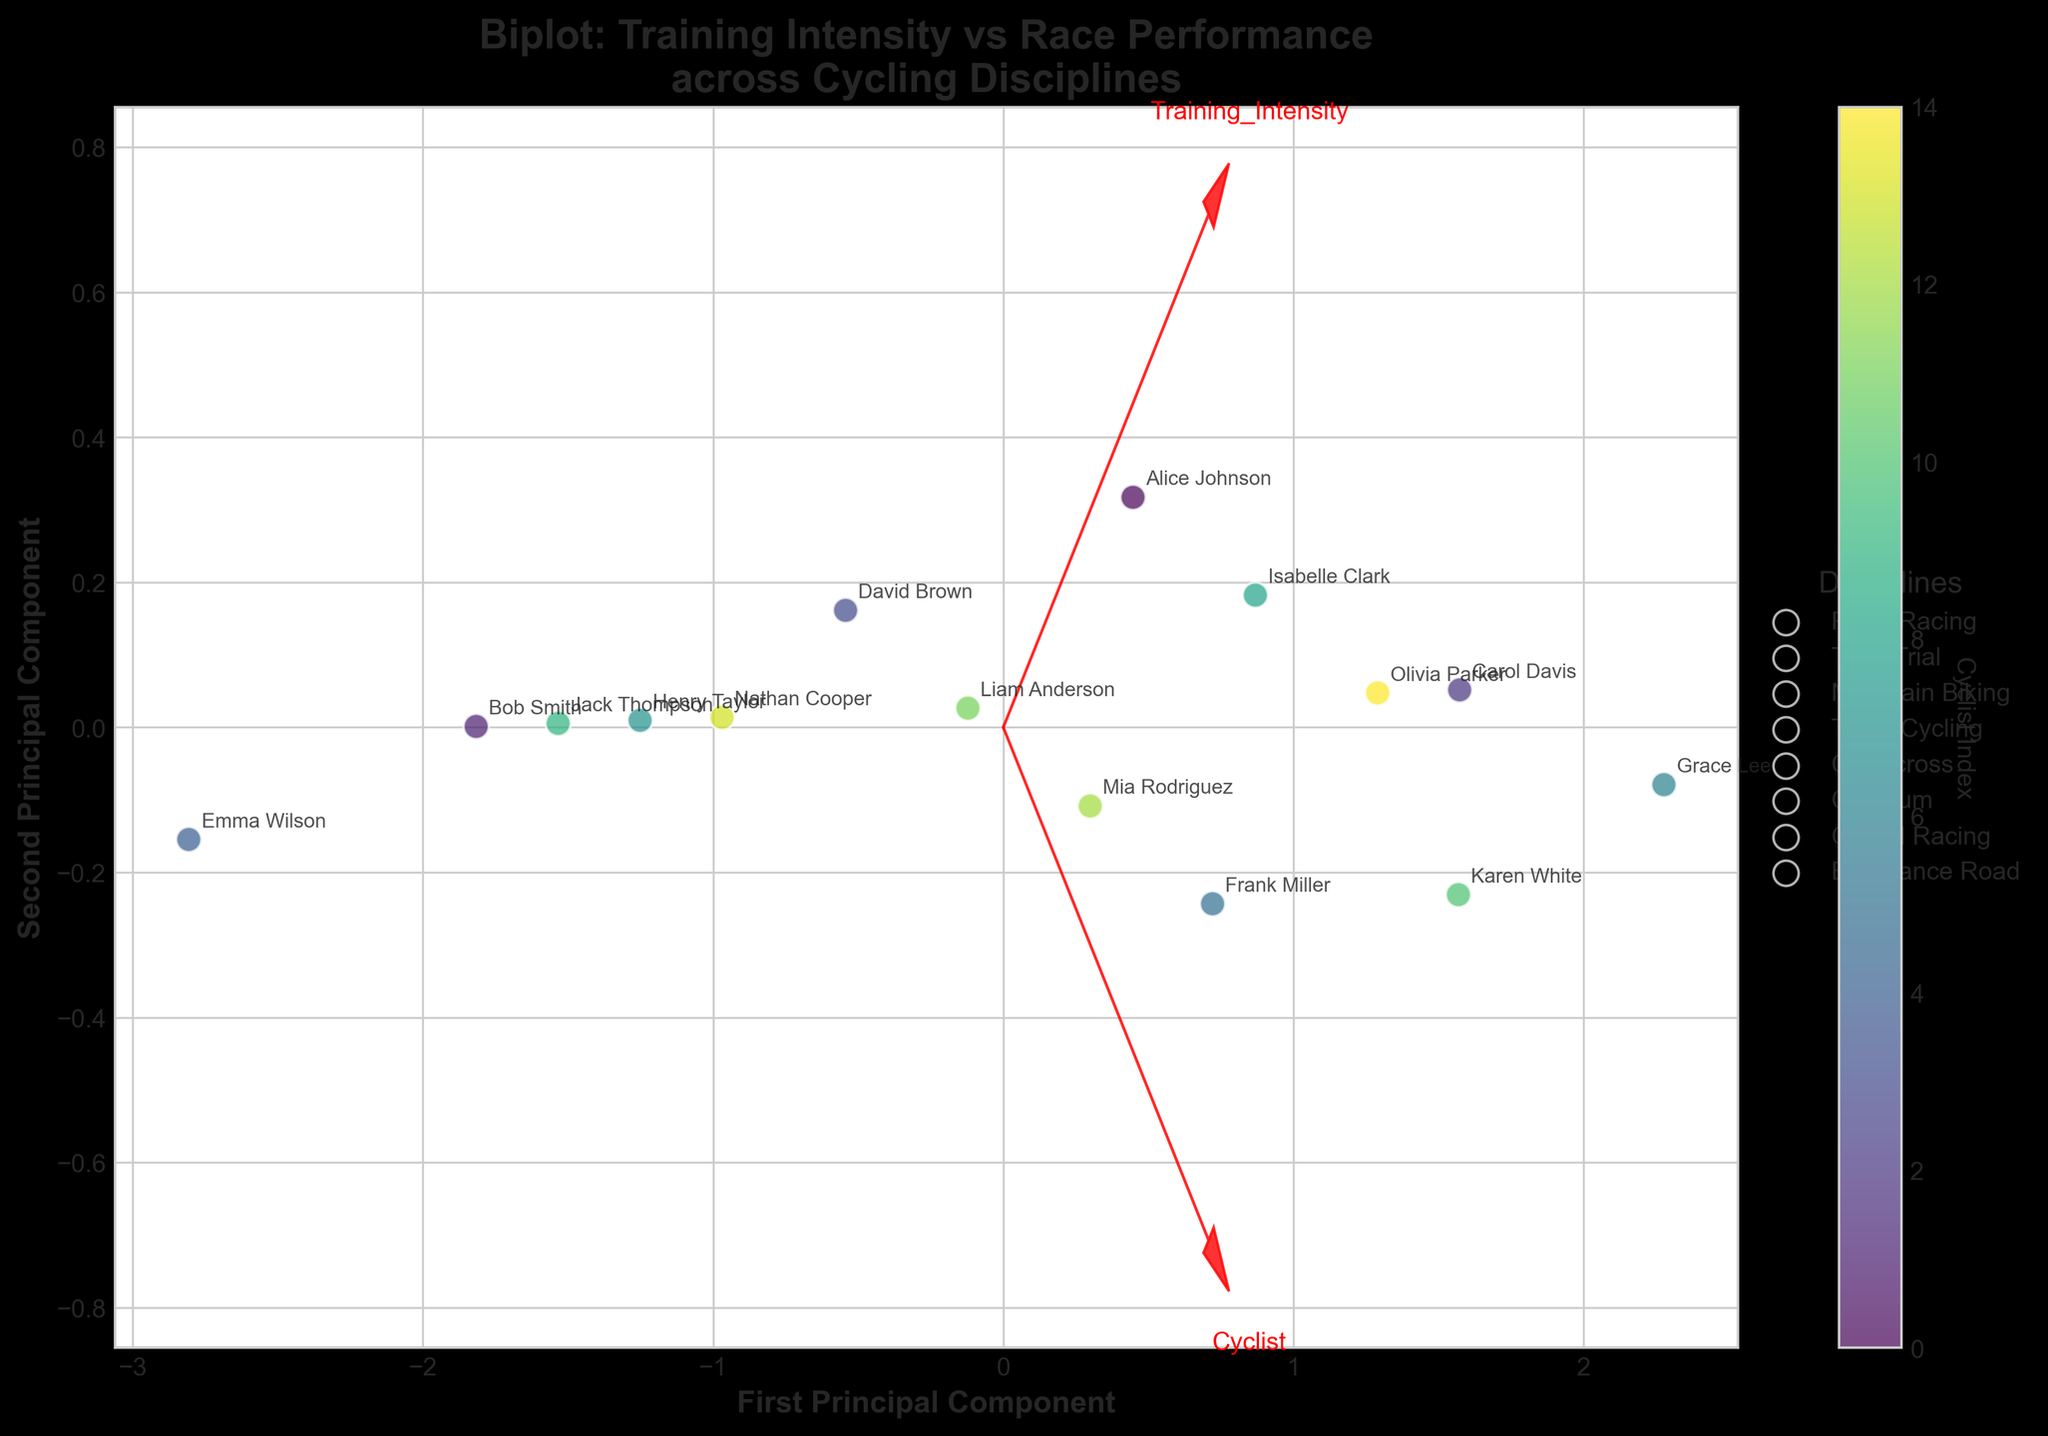what is the title of the figure? The title is often located at the top of the figure and it summarizes what the figure is about. For this figure, reading the text at the top reveals the title.
Answer: Biplot: Training Intensity vs Race Performance across Cycling Disciplines How many different cycling disciplines are represented in the plot? Each distinct cycling discipline is represented in the legend. Counting the number of items in the legend will give the total number of disciplines in the figure.
Answer: 7 Which cyclist corresponds to the highest value along the first principal component? To identify the cyclist, locate the data point that is furthest to the right along the x-axis (first principal component), and check the associated annotation.
Answer: Grace Lee Between Road Racing and Mountain Biking, which discipline shows a higher spread in Training Intensity and Race Performance? Examine the spread of data points for each discipline by observing the scatter plot locations. Road Racing data points should be compared with Mountain Biking data points to see which discipline has a wider spread on both axes.
Answer: Road Racing What do the red arrows in the biplot represent? The red arrows in a biplot usually represent the feature vectors in the PCA space. By looking at the figure, we can observe that the arrows are labeled which hints at the underlying features they represent.
Answer: Feature vectors for Training Intensity and Race Performance Is there any cyclist with nearly equal contribution to both principal components? Cycles with equal contributions to both principal components will be closer to the origin of the plot. Identifying the plotted point closest to zero on both axes will reveal this cyclist.
Answer: No, none are exactly equal but closest is Emma Wilson Which two disciplines appear to be the most similar in terms of PCA results? By observing the clusters of colors (representing disciplines) in the PCA plot, identify which two disciplines have data points that are most closely grouped together or overlap significantly.
Answer: Time Trial and Criterium Is there a positive correlation between Training Intensity and Race Performance implied by the plot? A positive correlation would be indicated by vectors pointing in similar directions. By examining the direction of the arrows for Training Intensity and Race Performance, we can determine the nature of their relationship.
Answer: Yes Which axis on the plot represents the first principal component? The axis labeled as 'First Principal Component' typically represents this. In the figure, the x-axis is labeled accordingly.
Answer: X-axis How does the position of Henry Taylor compare to the average position of Track Cycling cyclists on the plot? To answer this, identify Henry Taylor's data point and compare its position to the cluster of points representing Track Cycling cyclists.
Answer: Slightly below average on the y-axis 